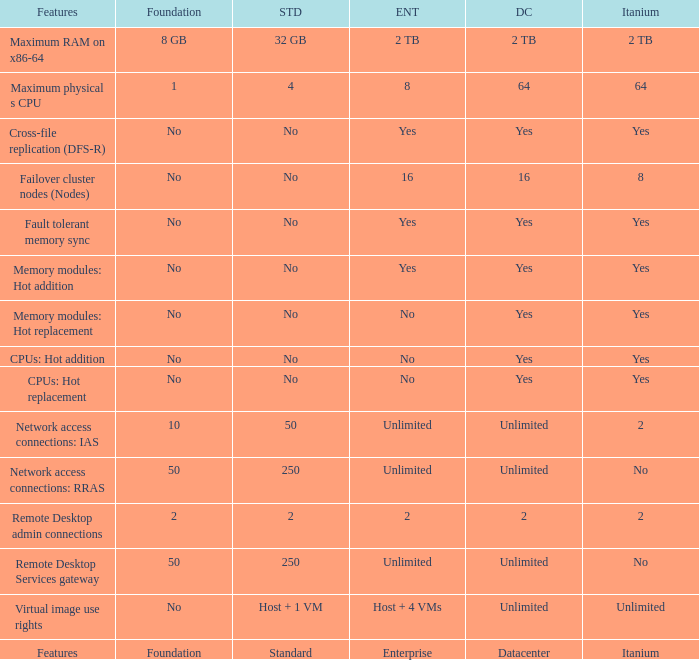What is the Datacenter for the Fault Tolerant Memory Sync Feature that has Yes for Itanium and No for Standard? Yes. 